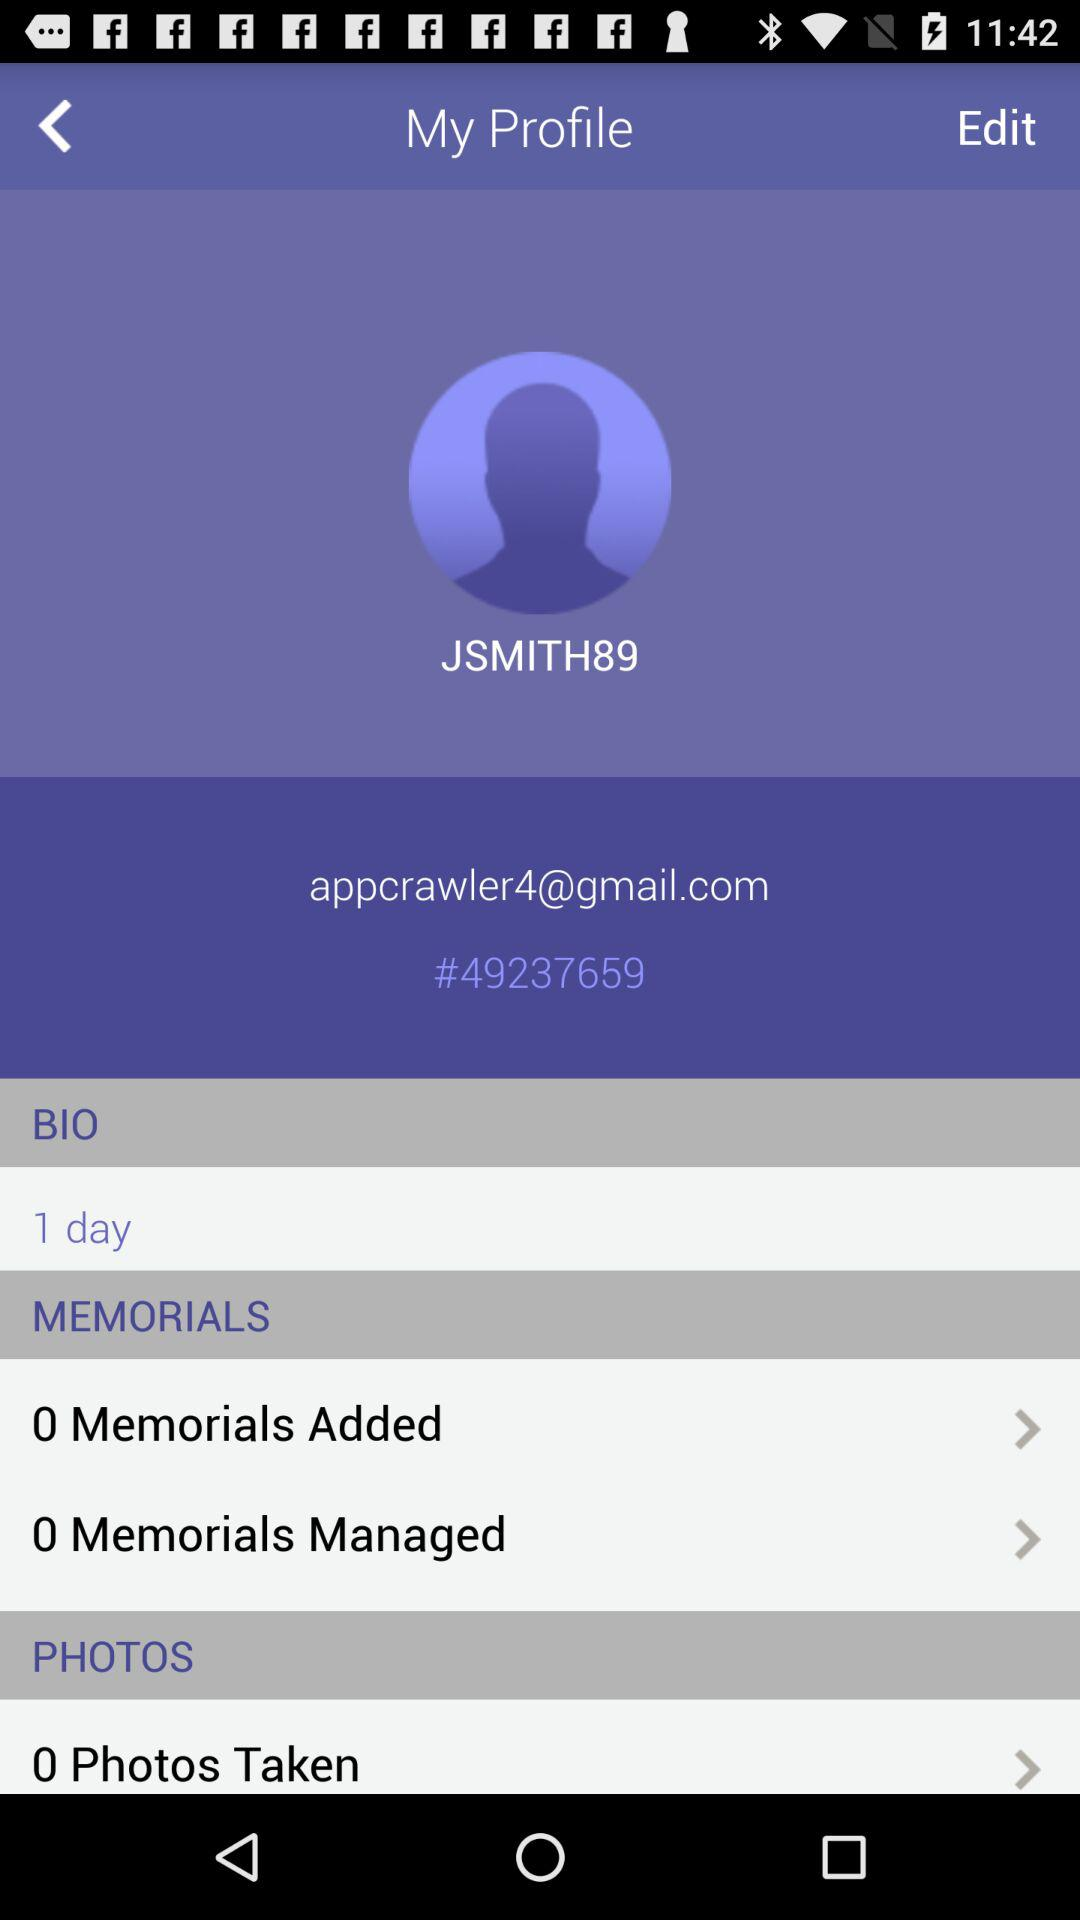What is the username? The username is "JSMITH89". 